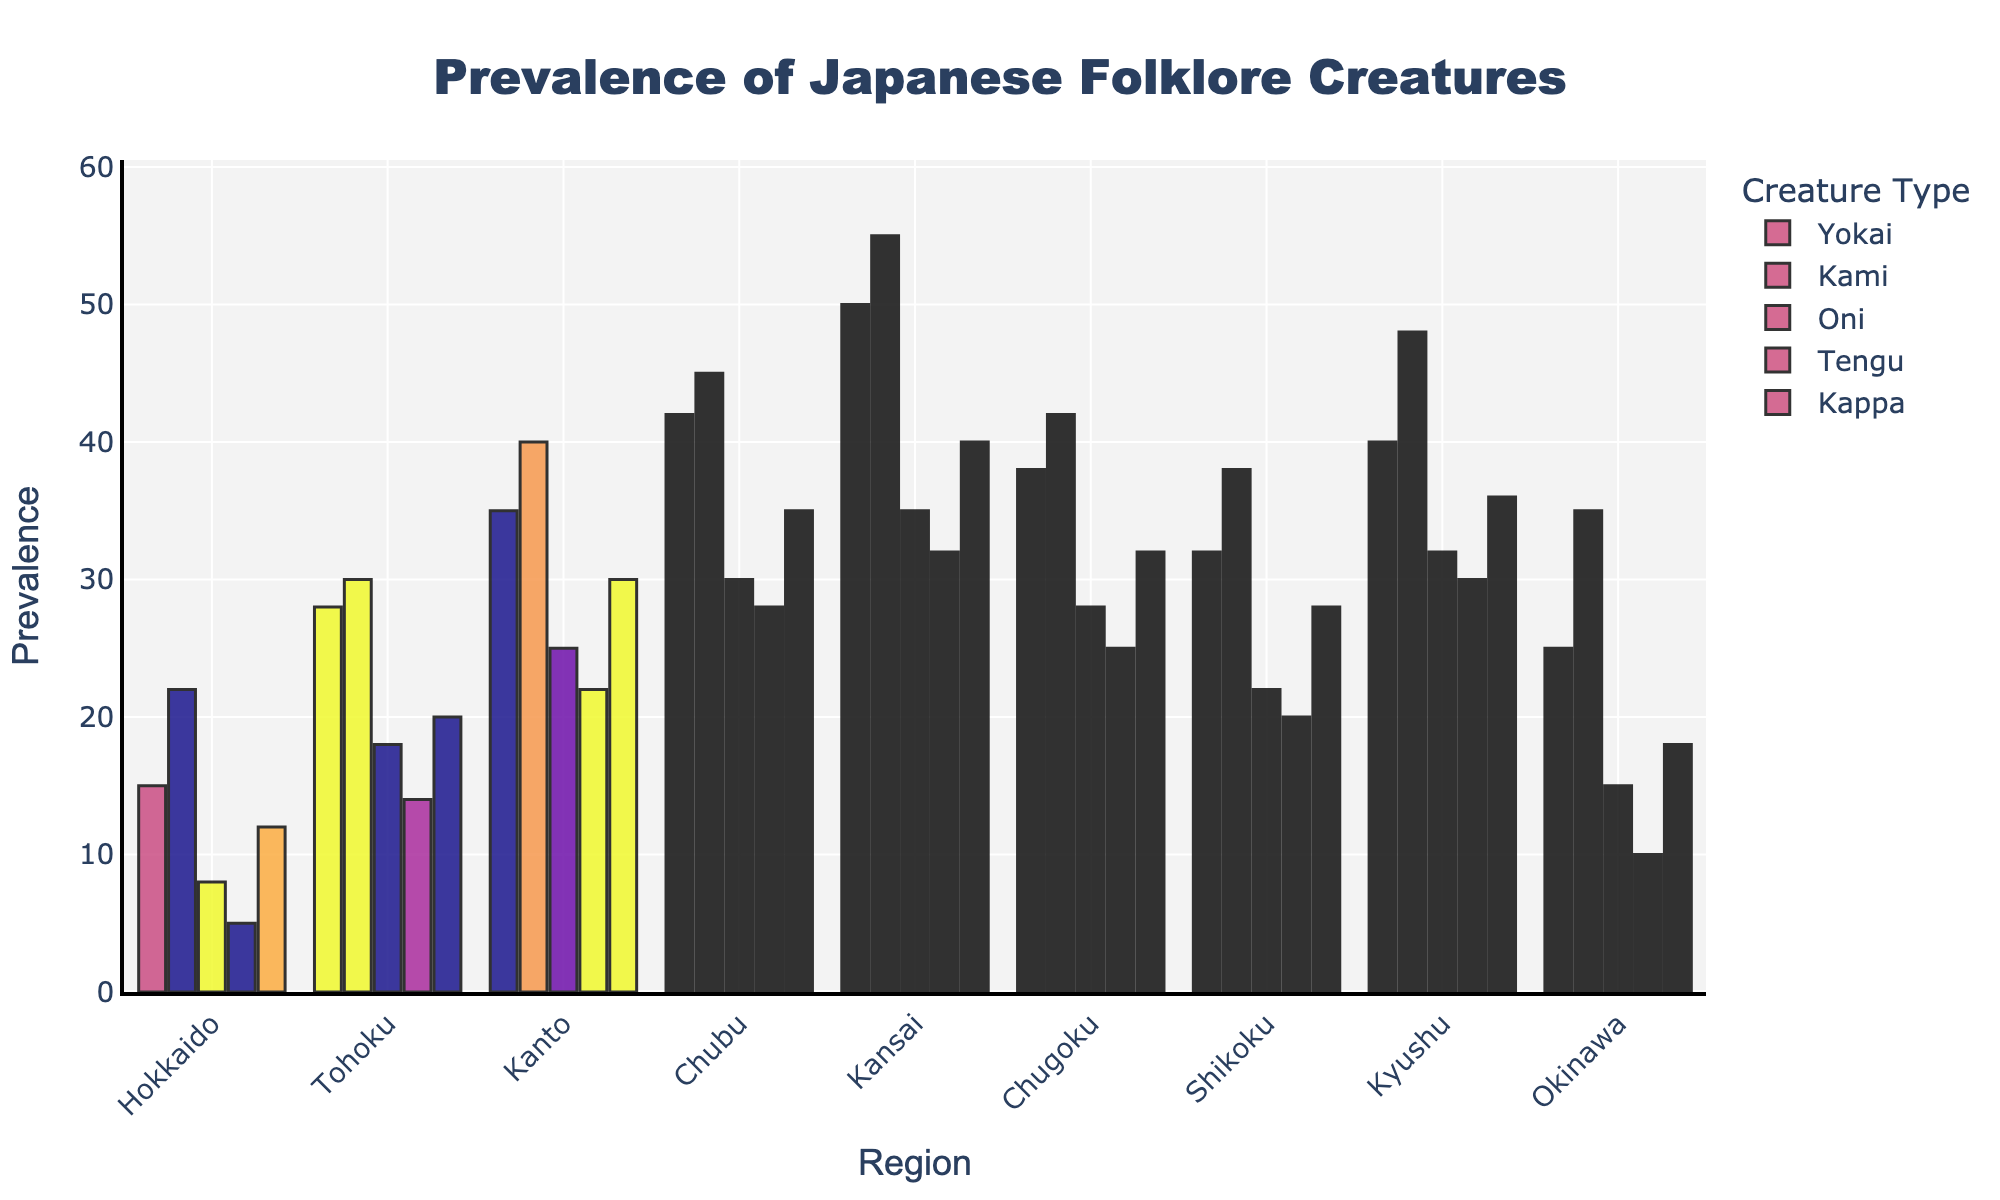Which region has the highest prevalence of Kami creatures? Looking at the plot, we can observe the highest bar corresponding to Kami creatures is in the Kansai region.
Answer: Kansai What is the total prevalence of Oni across all regions? By summing the prevalence of Oni in each region: 8 (Hokkaido) + 18 (Tohoku) + 25 (Kanto) + 30 (Chubu) + 35 (Kansai) + 28 (Chugoku) + 22 (Shikoku) + 32 (Kyushu) + 15 (Okinawa) = 213.
Answer: 213 Which creature is the most prevalent in Kyushu? By examining the bars for Kyushu, we see that the Kappa bar is the tallest, indicating that Kappa is the most prevalent.
Answer: Kappa How does the prevalence of Tengu in Kanto compare to Chubu? Comparing the heights of the Tengu bars for Kanto and Chubu, we see Kanto has 22 while Chubu has 28. Chubu has a higher prevalence of Tengu.
Answer: Chubu Which region has the lowest overall prevalence of Yokai creatures compared to Kami creatures? Hokkaido has the lowest prevalence of Yokai at 15 while having 22 Kami creatures. We determine this by comparing the heights of the Yokai bars across all regions.
Answer: Hokkaido What is the average prevalence of Kappa across the first three regions (Hokkaido, Tohoku, Kanto)? Summing the prevalence of Kappa across these regions: 12 (Hokkaido) + 20 (Tohoku) + 30 (Kanto) = 62, then dividing by 3 gives the average: 62/3 = 20.67.
Answer: 20.67 Are there any regions where the prevalence of Tengu is less than the prevalence of Oni? By comparing the heights of the Tengu and Oni bars for each region, we find Hokkaido (Tengu 5 < Oni 8) and Okinawa (Tengu 10 < Oni 15).
Answer: Yes, Hokkaido and Okinawa What is the difference in the prevalence of Kami between Chubu and Kansai regions? By subtracting the prevalence of Kami in Chubu from Kansai: 55 (Kansai) - 45 (Chubu) = 10.
Answer: 10 In which region is the prevalence of Yokai closer to the prevalence of Oni? By comparing the difference between Yokai and Oni in each region, Kansai has Yokai at 50 and Oni at 35, with a difference of 15, which is the smallest observed.
Answer: Kansai 